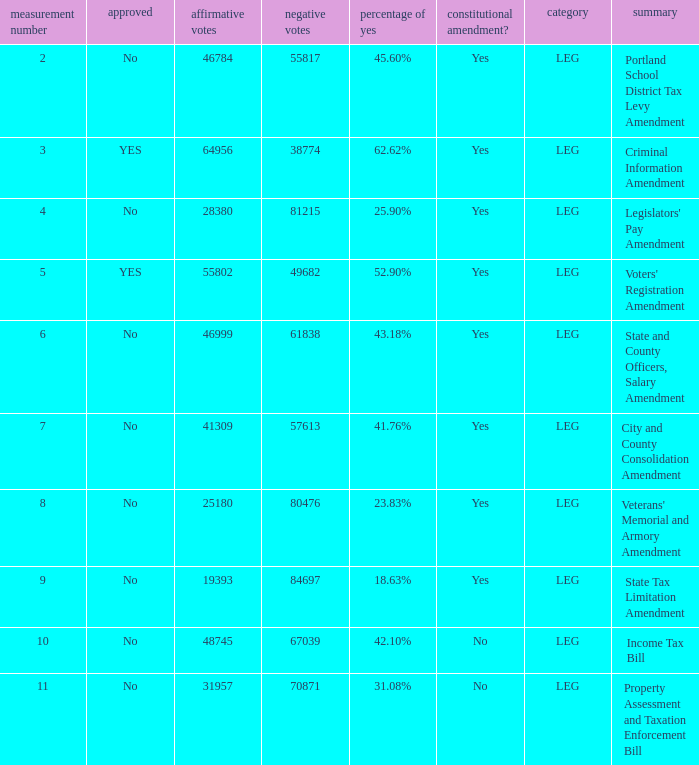How many yes votes made up 43.18% yes? 46999.0. 